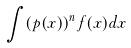<formula> <loc_0><loc_0><loc_500><loc_500>\int ( p ( x ) ) ^ { n } f ( x ) d x</formula> 